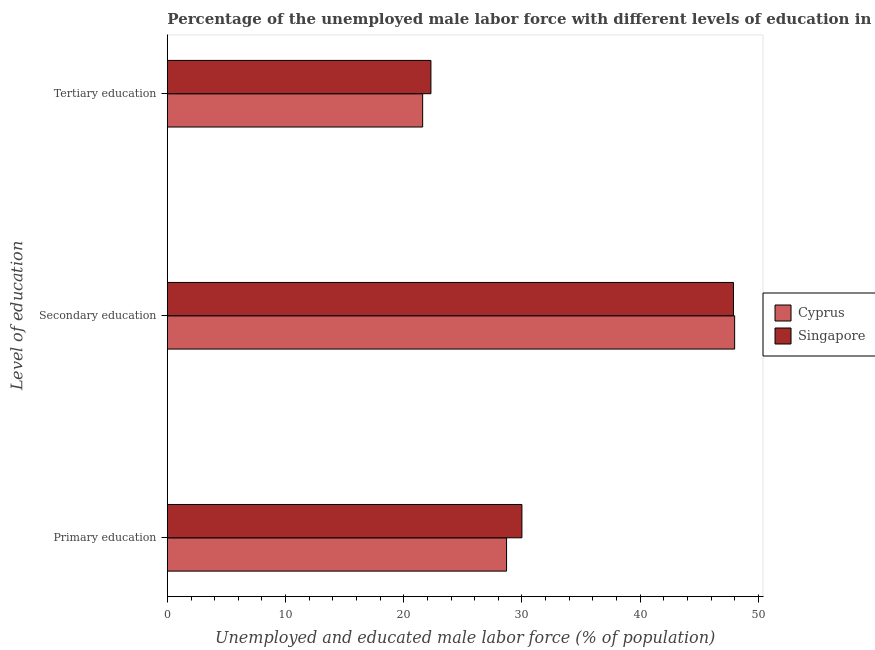How many different coloured bars are there?
Provide a short and direct response. 2. How many groups of bars are there?
Provide a short and direct response. 3. Are the number of bars per tick equal to the number of legend labels?
Offer a terse response. Yes. Are the number of bars on each tick of the Y-axis equal?
Provide a short and direct response. Yes. How many bars are there on the 3rd tick from the top?
Keep it short and to the point. 2. What is the label of the 2nd group of bars from the top?
Provide a short and direct response. Secondary education. What is the percentage of male labor force who received tertiary education in Cyprus?
Your answer should be very brief. 21.6. Across all countries, what is the minimum percentage of male labor force who received tertiary education?
Provide a succinct answer. 21.6. In which country was the percentage of male labor force who received tertiary education maximum?
Provide a short and direct response. Singapore. In which country was the percentage of male labor force who received primary education minimum?
Provide a short and direct response. Cyprus. What is the total percentage of male labor force who received secondary education in the graph?
Your answer should be very brief. 95.9. What is the difference between the percentage of male labor force who received secondary education in Cyprus and that in Singapore?
Offer a very short reply. 0.1. What is the difference between the percentage of male labor force who received secondary education in Singapore and the percentage of male labor force who received tertiary education in Cyprus?
Make the answer very short. 26.3. What is the average percentage of male labor force who received secondary education per country?
Ensure brevity in your answer.  47.95. What is the difference between the percentage of male labor force who received primary education and percentage of male labor force who received secondary education in Singapore?
Offer a terse response. -17.9. In how many countries, is the percentage of male labor force who received tertiary education greater than 34 %?
Offer a terse response. 0. What is the ratio of the percentage of male labor force who received primary education in Cyprus to that in Singapore?
Ensure brevity in your answer.  0.96. Is the percentage of male labor force who received secondary education in Singapore less than that in Cyprus?
Your response must be concise. Yes. Is the difference between the percentage of male labor force who received secondary education in Cyprus and Singapore greater than the difference between the percentage of male labor force who received primary education in Cyprus and Singapore?
Provide a short and direct response. Yes. What is the difference between the highest and the second highest percentage of male labor force who received tertiary education?
Your response must be concise. 0.7. What is the difference between the highest and the lowest percentage of male labor force who received tertiary education?
Ensure brevity in your answer.  0.7. What does the 1st bar from the top in Secondary education represents?
Provide a succinct answer. Singapore. What does the 1st bar from the bottom in Secondary education represents?
Give a very brief answer. Cyprus. Is it the case that in every country, the sum of the percentage of male labor force who received primary education and percentage of male labor force who received secondary education is greater than the percentage of male labor force who received tertiary education?
Offer a very short reply. Yes. Are all the bars in the graph horizontal?
Offer a very short reply. Yes. What is the difference between two consecutive major ticks on the X-axis?
Give a very brief answer. 10. How are the legend labels stacked?
Your answer should be very brief. Vertical. What is the title of the graph?
Give a very brief answer. Percentage of the unemployed male labor force with different levels of education in countries. What is the label or title of the X-axis?
Ensure brevity in your answer.  Unemployed and educated male labor force (% of population). What is the label or title of the Y-axis?
Your response must be concise. Level of education. What is the Unemployed and educated male labor force (% of population) in Cyprus in Primary education?
Give a very brief answer. 28.7. What is the Unemployed and educated male labor force (% of population) of Singapore in Secondary education?
Make the answer very short. 47.9. What is the Unemployed and educated male labor force (% of population) in Cyprus in Tertiary education?
Your answer should be very brief. 21.6. What is the Unemployed and educated male labor force (% of population) in Singapore in Tertiary education?
Offer a terse response. 22.3. Across all Level of education, what is the maximum Unemployed and educated male labor force (% of population) of Cyprus?
Make the answer very short. 48. Across all Level of education, what is the maximum Unemployed and educated male labor force (% of population) of Singapore?
Give a very brief answer. 47.9. Across all Level of education, what is the minimum Unemployed and educated male labor force (% of population) of Cyprus?
Ensure brevity in your answer.  21.6. Across all Level of education, what is the minimum Unemployed and educated male labor force (% of population) of Singapore?
Offer a very short reply. 22.3. What is the total Unemployed and educated male labor force (% of population) of Cyprus in the graph?
Give a very brief answer. 98.3. What is the total Unemployed and educated male labor force (% of population) of Singapore in the graph?
Your response must be concise. 100.2. What is the difference between the Unemployed and educated male labor force (% of population) of Cyprus in Primary education and that in Secondary education?
Keep it short and to the point. -19.3. What is the difference between the Unemployed and educated male labor force (% of population) of Singapore in Primary education and that in Secondary education?
Offer a terse response. -17.9. What is the difference between the Unemployed and educated male labor force (% of population) in Cyprus in Secondary education and that in Tertiary education?
Provide a short and direct response. 26.4. What is the difference between the Unemployed and educated male labor force (% of population) in Singapore in Secondary education and that in Tertiary education?
Ensure brevity in your answer.  25.6. What is the difference between the Unemployed and educated male labor force (% of population) of Cyprus in Primary education and the Unemployed and educated male labor force (% of population) of Singapore in Secondary education?
Offer a terse response. -19.2. What is the difference between the Unemployed and educated male labor force (% of population) of Cyprus in Secondary education and the Unemployed and educated male labor force (% of population) of Singapore in Tertiary education?
Keep it short and to the point. 25.7. What is the average Unemployed and educated male labor force (% of population) of Cyprus per Level of education?
Give a very brief answer. 32.77. What is the average Unemployed and educated male labor force (% of population) in Singapore per Level of education?
Provide a short and direct response. 33.4. What is the difference between the Unemployed and educated male labor force (% of population) in Cyprus and Unemployed and educated male labor force (% of population) in Singapore in Primary education?
Provide a short and direct response. -1.3. What is the difference between the Unemployed and educated male labor force (% of population) in Cyprus and Unemployed and educated male labor force (% of population) in Singapore in Secondary education?
Keep it short and to the point. 0.1. What is the ratio of the Unemployed and educated male labor force (% of population) of Cyprus in Primary education to that in Secondary education?
Offer a very short reply. 0.6. What is the ratio of the Unemployed and educated male labor force (% of population) in Singapore in Primary education to that in Secondary education?
Give a very brief answer. 0.63. What is the ratio of the Unemployed and educated male labor force (% of population) in Cyprus in Primary education to that in Tertiary education?
Provide a succinct answer. 1.33. What is the ratio of the Unemployed and educated male labor force (% of population) of Singapore in Primary education to that in Tertiary education?
Offer a terse response. 1.35. What is the ratio of the Unemployed and educated male labor force (% of population) of Cyprus in Secondary education to that in Tertiary education?
Keep it short and to the point. 2.22. What is the ratio of the Unemployed and educated male labor force (% of population) in Singapore in Secondary education to that in Tertiary education?
Keep it short and to the point. 2.15. What is the difference between the highest and the second highest Unemployed and educated male labor force (% of population) of Cyprus?
Your response must be concise. 19.3. What is the difference between the highest and the second highest Unemployed and educated male labor force (% of population) of Singapore?
Keep it short and to the point. 17.9. What is the difference between the highest and the lowest Unemployed and educated male labor force (% of population) of Cyprus?
Your answer should be very brief. 26.4. What is the difference between the highest and the lowest Unemployed and educated male labor force (% of population) of Singapore?
Offer a terse response. 25.6. 